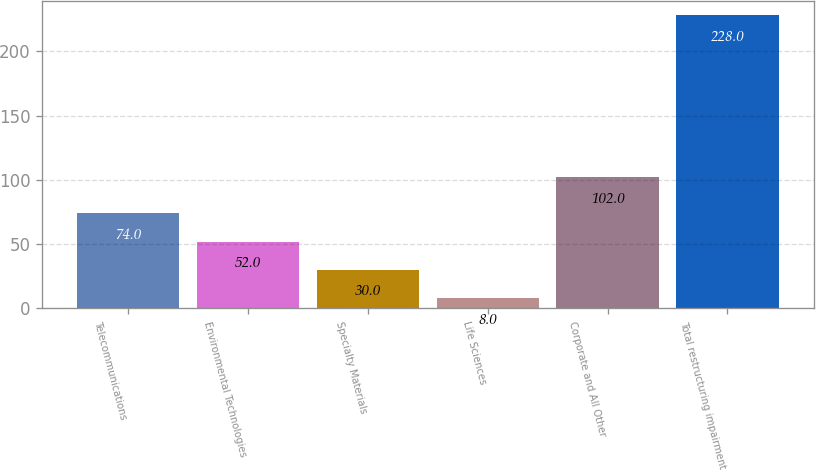Convert chart. <chart><loc_0><loc_0><loc_500><loc_500><bar_chart><fcel>Telecommunications<fcel>Environmental Technologies<fcel>Specialty Materials<fcel>Life Sciences<fcel>Corporate and All Other<fcel>Total restructuring impairment<nl><fcel>74<fcel>52<fcel>30<fcel>8<fcel>102<fcel>228<nl></chart> 